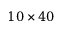<formula> <loc_0><loc_0><loc_500><loc_500>1 0 \times 4 0</formula> 